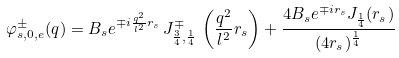Convert formula to latex. <formula><loc_0><loc_0><loc_500><loc_500>\varphi _ { s , 0 , e } ^ { \pm } ( q ) = B _ { s } e ^ { \mp i \frac { q ^ { 2 } } { l ^ { 2 } } r _ { s } } \, J _ { \frac { 3 } { 4 } , \frac { 1 } { 4 } } ^ { \mp } \, \left ( \frac { q ^ { 2 } } { l ^ { 2 } } r _ { s } \right ) + \frac { 4 B _ { s } e ^ { \mp i r _ { s } } J _ { \frac { 1 } { 4 } } ( r _ { s } ) } { ( 4 r _ { s } ) ^ { \frac { 1 } { 4 } } }</formula> 